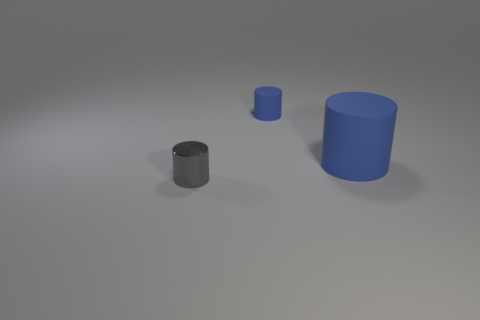There is a thing behind the big blue object; is its size the same as the cylinder that is in front of the big blue matte object?
Provide a short and direct response. Yes. How many objects are either small cylinders behind the big blue rubber cylinder or big blue matte objects?
Make the answer very short. 2. There is a cylinder that is behind the big thing; what is its material?
Ensure brevity in your answer.  Rubber. What is the gray thing made of?
Ensure brevity in your answer.  Metal. The small cylinder right of the tiny cylinder that is in front of the blue rubber cylinder that is left of the big blue matte cylinder is made of what material?
Keep it short and to the point. Rubber. Is there anything else that is made of the same material as the big cylinder?
Your answer should be compact. Yes. Is the size of the gray shiny cylinder the same as the matte cylinder behind the big thing?
Make the answer very short. Yes. What number of objects are either blue rubber cylinders that are behind the big rubber cylinder or small things that are behind the gray cylinder?
Your response must be concise. 1. What is the color of the rubber object that is in front of the small rubber cylinder?
Make the answer very short. Blue. Is there a tiny cylinder that is in front of the tiny object that is in front of the small blue rubber cylinder?
Make the answer very short. No. 